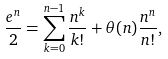<formula> <loc_0><loc_0><loc_500><loc_500>\frac { e ^ { n } } { 2 } = \sum _ { k = 0 } ^ { n - 1 } \frac { n ^ { k } } { k ! } + \theta ( n ) \frac { n ^ { n } } { n ! } ,</formula> 